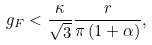Convert formula to latex. <formula><loc_0><loc_0><loc_500><loc_500>g _ { F } < \frac { \kappa } { \sqrt { 3 } } \frac { r } { \pi \left ( 1 + \alpha \right ) } ,</formula> 